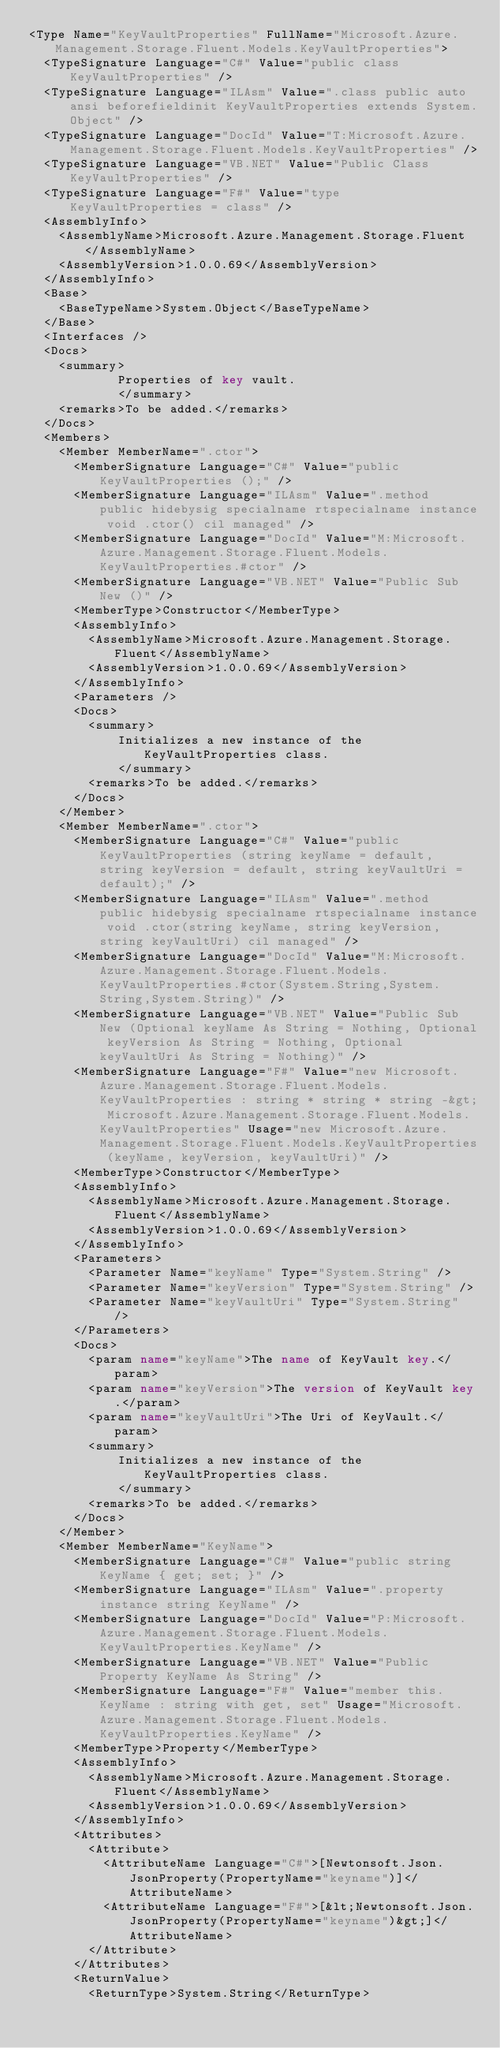Convert code to text. <code><loc_0><loc_0><loc_500><loc_500><_XML_><Type Name="KeyVaultProperties" FullName="Microsoft.Azure.Management.Storage.Fluent.Models.KeyVaultProperties">
  <TypeSignature Language="C#" Value="public class KeyVaultProperties" />
  <TypeSignature Language="ILAsm" Value=".class public auto ansi beforefieldinit KeyVaultProperties extends System.Object" />
  <TypeSignature Language="DocId" Value="T:Microsoft.Azure.Management.Storage.Fluent.Models.KeyVaultProperties" />
  <TypeSignature Language="VB.NET" Value="Public Class KeyVaultProperties" />
  <TypeSignature Language="F#" Value="type KeyVaultProperties = class" />
  <AssemblyInfo>
    <AssemblyName>Microsoft.Azure.Management.Storage.Fluent</AssemblyName>
    <AssemblyVersion>1.0.0.69</AssemblyVersion>
  </AssemblyInfo>
  <Base>
    <BaseTypeName>System.Object</BaseTypeName>
  </Base>
  <Interfaces />
  <Docs>
    <summary>
            Properties of key vault.
            </summary>
    <remarks>To be added.</remarks>
  </Docs>
  <Members>
    <Member MemberName=".ctor">
      <MemberSignature Language="C#" Value="public KeyVaultProperties ();" />
      <MemberSignature Language="ILAsm" Value=".method public hidebysig specialname rtspecialname instance void .ctor() cil managed" />
      <MemberSignature Language="DocId" Value="M:Microsoft.Azure.Management.Storage.Fluent.Models.KeyVaultProperties.#ctor" />
      <MemberSignature Language="VB.NET" Value="Public Sub New ()" />
      <MemberType>Constructor</MemberType>
      <AssemblyInfo>
        <AssemblyName>Microsoft.Azure.Management.Storage.Fluent</AssemblyName>
        <AssemblyVersion>1.0.0.69</AssemblyVersion>
      </AssemblyInfo>
      <Parameters />
      <Docs>
        <summary>
            Initializes a new instance of the KeyVaultProperties class.
            </summary>
        <remarks>To be added.</remarks>
      </Docs>
    </Member>
    <Member MemberName=".ctor">
      <MemberSignature Language="C#" Value="public KeyVaultProperties (string keyName = default, string keyVersion = default, string keyVaultUri = default);" />
      <MemberSignature Language="ILAsm" Value=".method public hidebysig specialname rtspecialname instance void .ctor(string keyName, string keyVersion, string keyVaultUri) cil managed" />
      <MemberSignature Language="DocId" Value="M:Microsoft.Azure.Management.Storage.Fluent.Models.KeyVaultProperties.#ctor(System.String,System.String,System.String)" />
      <MemberSignature Language="VB.NET" Value="Public Sub New (Optional keyName As String = Nothing, Optional keyVersion As String = Nothing, Optional keyVaultUri As String = Nothing)" />
      <MemberSignature Language="F#" Value="new Microsoft.Azure.Management.Storage.Fluent.Models.KeyVaultProperties : string * string * string -&gt; Microsoft.Azure.Management.Storage.Fluent.Models.KeyVaultProperties" Usage="new Microsoft.Azure.Management.Storage.Fluent.Models.KeyVaultProperties (keyName, keyVersion, keyVaultUri)" />
      <MemberType>Constructor</MemberType>
      <AssemblyInfo>
        <AssemblyName>Microsoft.Azure.Management.Storage.Fluent</AssemblyName>
        <AssemblyVersion>1.0.0.69</AssemblyVersion>
      </AssemblyInfo>
      <Parameters>
        <Parameter Name="keyName" Type="System.String" />
        <Parameter Name="keyVersion" Type="System.String" />
        <Parameter Name="keyVaultUri" Type="System.String" />
      </Parameters>
      <Docs>
        <param name="keyName">The name of KeyVault key.</param>
        <param name="keyVersion">The version of KeyVault key.</param>
        <param name="keyVaultUri">The Uri of KeyVault.</param>
        <summary>
            Initializes a new instance of the KeyVaultProperties class.
            </summary>
        <remarks>To be added.</remarks>
      </Docs>
    </Member>
    <Member MemberName="KeyName">
      <MemberSignature Language="C#" Value="public string KeyName { get; set; }" />
      <MemberSignature Language="ILAsm" Value=".property instance string KeyName" />
      <MemberSignature Language="DocId" Value="P:Microsoft.Azure.Management.Storage.Fluent.Models.KeyVaultProperties.KeyName" />
      <MemberSignature Language="VB.NET" Value="Public Property KeyName As String" />
      <MemberSignature Language="F#" Value="member this.KeyName : string with get, set" Usage="Microsoft.Azure.Management.Storage.Fluent.Models.KeyVaultProperties.KeyName" />
      <MemberType>Property</MemberType>
      <AssemblyInfo>
        <AssemblyName>Microsoft.Azure.Management.Storage.Fluent</AssemblyName>
        <AssemblyVersion>1.0.0.69</AssemblyVersion>
      </AssemblyInfo>
      <Attributes>
        <Attribute>
          <AttributeName Language="C#">[Newtonsoft.Json.JsonProperty(PropertyName="keyname")]</AttributeName>
          <AttributeName Language="F#">[&lt;Newtonsoft.Json.JsonProperty(PropertyName="keyname")&gt;]</AttributeName>
        </Attribute>
      </Attributes>
      <ReturnValue>
        <ReturnType>System.String</ReturnType></code> 